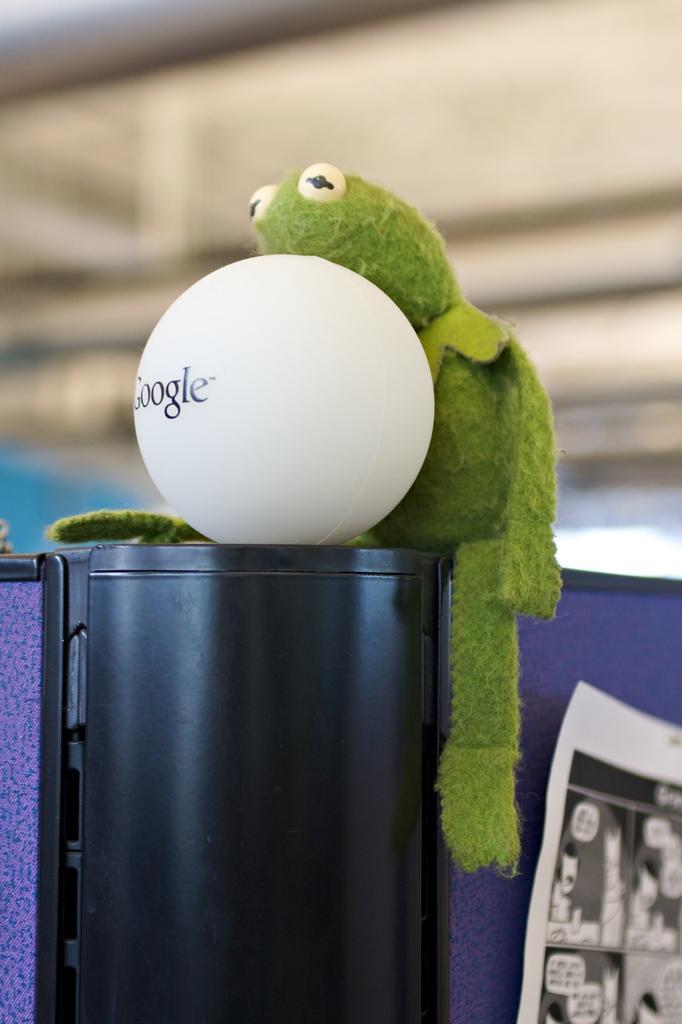How would you summarize this image in a sentence or two? In this image, we can see white ball and toy is placed on the black color object. Right side of the image, we can see a poster. Background there is a blur view. 